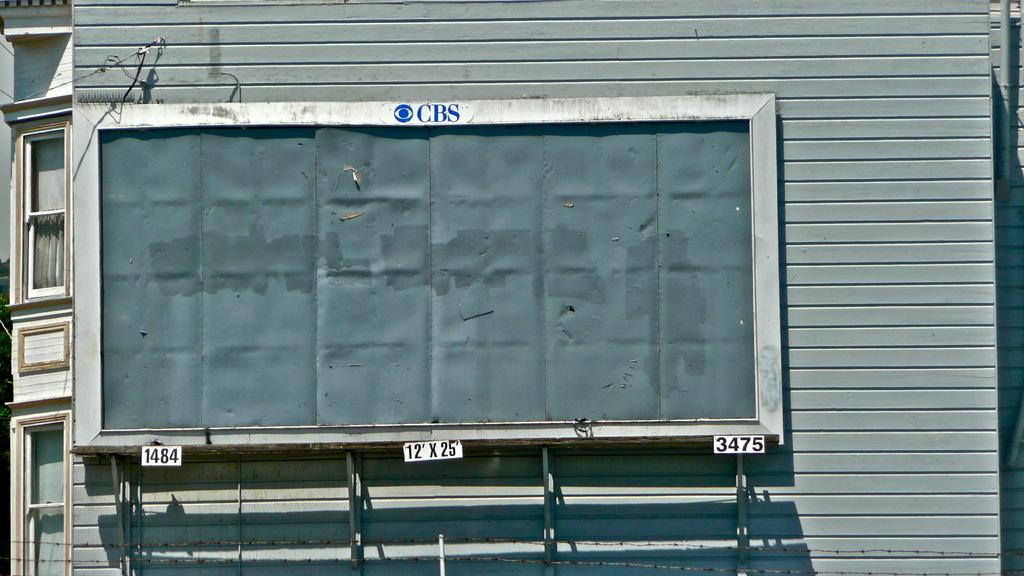What can be seen in the left corner of the image? There are windows in the left corner of the image. What is located in the right corner of the image? There are objects in the right corner of the image. What is the closest object to the viewer in the image? There is an object in the foreground of the image. What is visible behind the objects in the image? The background of the image appears to be a wall. How does the jellyfish move around in the image? There is no jellyfish present in the image. What is the chance of winning a prize in the image? There is no mention of a prize or chance in the image. 